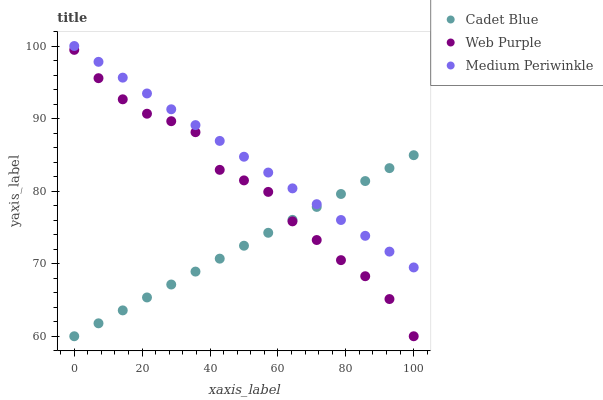Does Cadet Blue have the minimum area under the curve?
Answer yes or no. Yes. Does Medium Periwinkle have the maximum area under the curve?
Answer yes or no. Yes. Does Medium Periwinkle have the minimum area under the curve?
Answer yes or no. No. Does Cadet Blue have the maximum area under the curve?
Answer yes or no. No. Is Cadet Blue the smoothest?
Answer yes or no. Yes. Is Web Purple the roughest?
Answer yes or no. Yes. Is Medium Periwinkle the smoothest?
Answer yes or no. No. Is Medium Periwinkle the roughest?
Answer yes or no. No. Does Web Purple have the lowest value?
Answer yes or no. Yes. Does Medium Periwinkle have the lowest value?
Answer yes or no. No. Does Medium Periwinkle have the highest value?
Answer yes or no. Yes. Does Cadet Blue have the highest value?
Answer yes or no. No. Is Web Purple less than Medium Periwinkle?
Answer yes or no. Yes. Is Medium Periwinkle greater than Web Purple?
Answer yes or no. Yes. Does Cadet Blue intersect Web Purple?
Answer yes or no. Yes. Is Cadet Blue less than Web Purple?
Answer yes or no. No. Is Cadet Blue greater than Web Purple?
Answer yes or no. No. Does Web Purple intersect Medium Periwinkle?
Answer yes or no. No. 